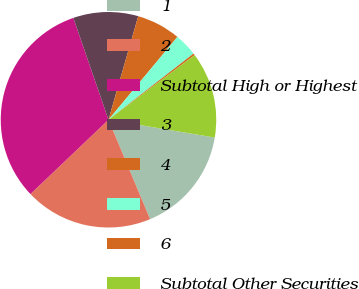Convert chart. <chart><loc_0><loc_0><loc_500><loc_500><pie_chart><fcel>1<fcel>2<fcel>Subtotal High or Highest<fcel>3<fcel>4<fcel>5<fcel>6<fcel>Subtotal Other Securities<nl><fcel>16.05%<fcel>19.2%<fcel>31.82%<fcel>9.74%<fcel>6.59%<fcel>3.43%<fcel>0.28%<fcel>12.89%<nl></chart> 